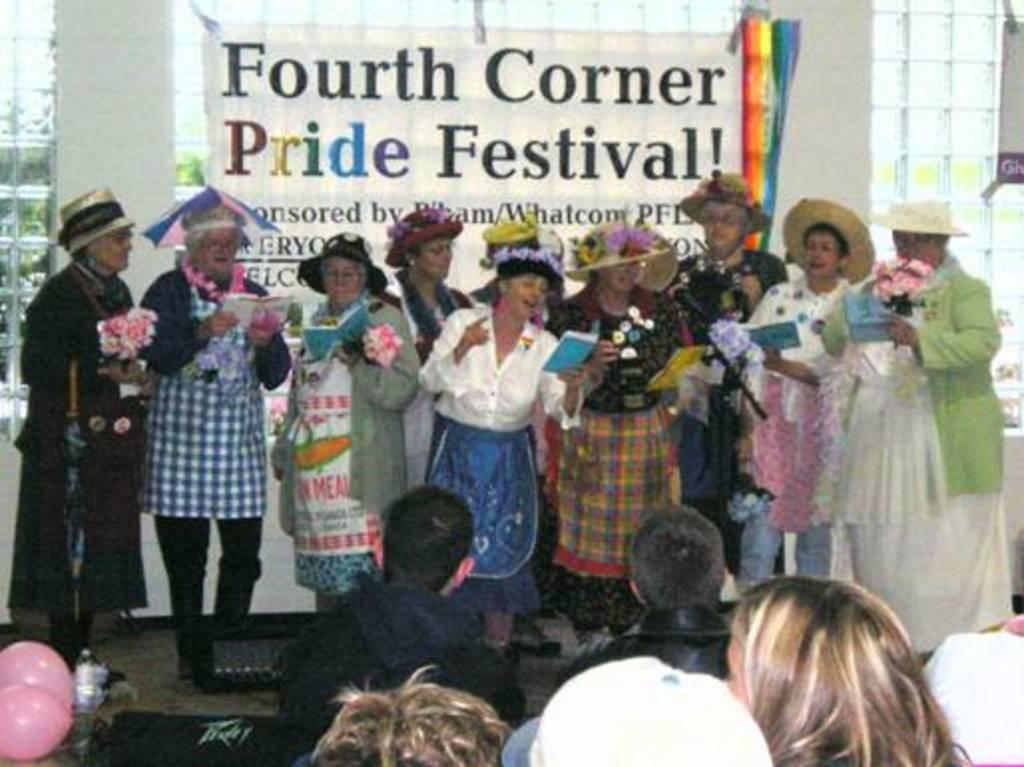Could you give a brief overview of what you see in this image? The picture is taken inside a hall. In the foreground there are few people. In the background there are many people holding books, few are holding bouquet. All of them are wearing hats. In the background there is glass wall, banner Here there are balloons and bottle. Through the glass wall we can see outside there are trees. 